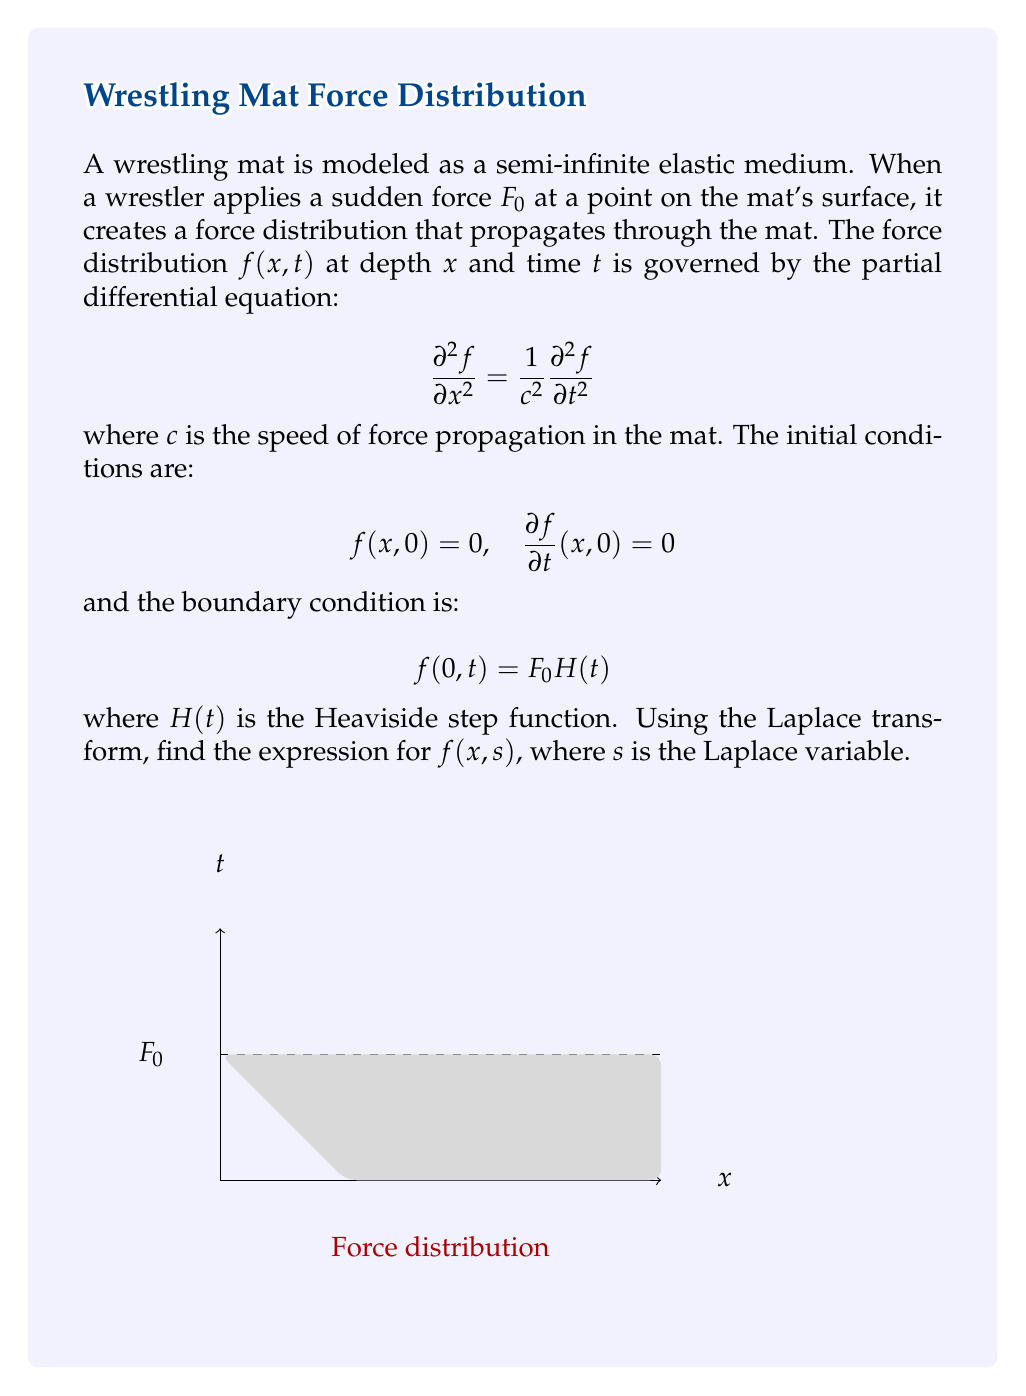Teach me how to tackle this problem. Let's solve this problem step by step using the Laplace transform method:

1) First, we take the Laplace transform of the PDE with respect to $t$:

   $$\mathcal{L}\left\{\frac{\partial^2 f}{\partial x^2}\right\} = \frac{1}{c^2}\mathcal{L}\left\{\frac{\partial^2 f}{\partial t^2}\right\}$$

2) Using the properties of the Laplace transform:

   $$\frac{d^2 F}{dx^2} = \frac{1}{c^2}[s^2F(x,s) - sf(x,0) - f_t(x,0)]$$

   where $F(x,s) = \mathcal{L}\{f(x,t)\}$

3) Applying the initial conditions:

   $$\frac{d^2 F}{dx^2} = \frac{s^2}{c^2}F(x,s)$$

4) This is a second-order ODE in $x$. Its general solution is:

   $$F(x,s) = A(s)e^{\frac{sx}{c}} + B(s)e^{-\frac{sx}{c}}$$

5) Since the mat is semi-infinite, we can assume that $F(x,s) \to 0$ as $x \to \infty$. This implies $A(s) = 0$. So:

   $$F(x,s) = B(s)e^{-\frac{sx}{c}}$$

6) Now, we use the boundary condition. Taking the Laplace transform of $f(0,t) = F_0 H(t)$:

   $$F(0,s) = \frac{F_0}{s}$$

7) Applying this to our solution:

   $$B(s) = \frac{F_0}{s}$$

8) Therefore, the final solution in the Laplace domain is:

   $$F(x,s) = \frac{F_0}{s}e^{-\frac{sx}{c}}$$

This expression represents the Laplace transform of the force distribution in the wrestling mat.
Answer: $F(x,s) = \frac{F_0}{s}e^{-\frac{sx}{c}}$ 